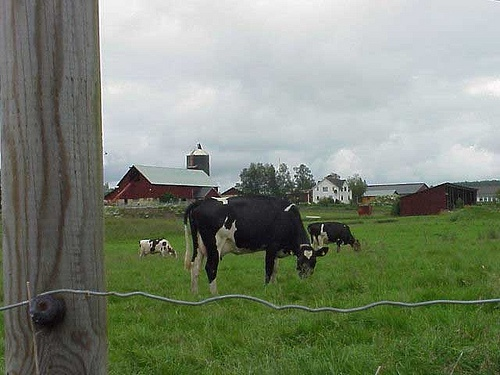Describe the objects in this image and their specific colors. I can see cow in gray, black, and darkgreen tones, cow in gray, black, and darkgreen tones, and cow in gray, darkgreen, black, and darkgray tones in this image. 